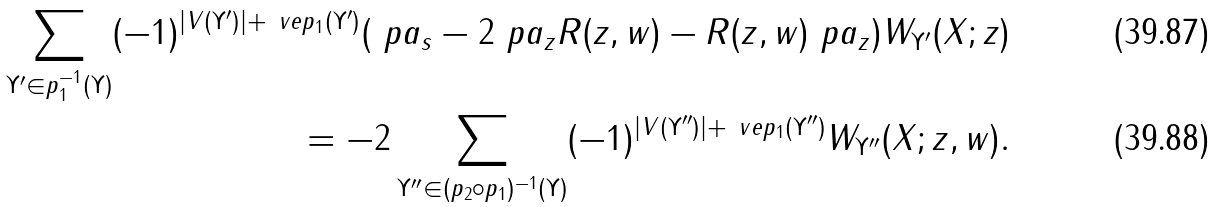<formula> <loc_0><loc_0><loc_500><loc_500>\sum _ { \Upsilon ^ { \prime } \in p _ { 1 } ^ { - 1 } ( \Upsilon ) } ( - 1 ) ^ { | V ( \Upsilon ^ { \prime } ) | + \ v e p _ { 1 } ( \Upsilon ^ { \prime } ) } ( \ p a _ { s } - 2 \ p a _ { z } R ( z , w ) - R ( z , w ) \ p a _ { z } ) W _ { \Upsilon ^ { \prime } } ( X ; z ) \\ = - 2 \sum _ { \Upsilon ^ { \prime \prime } \in ( p _ { 2 } \circ p _ { 1 } ) ^ { - 1 } ( \Upsilon ) } ( - 1 ) ^ { | V ( \Upsilon ^ { \prime \prime } ) | + \ v e p _ { 1 } ( \Upsilon ^ { \prime \prime } ) } W _ { \Upsilon ^ { \prime \prime } } ( X ; z , w ) .</formula> 